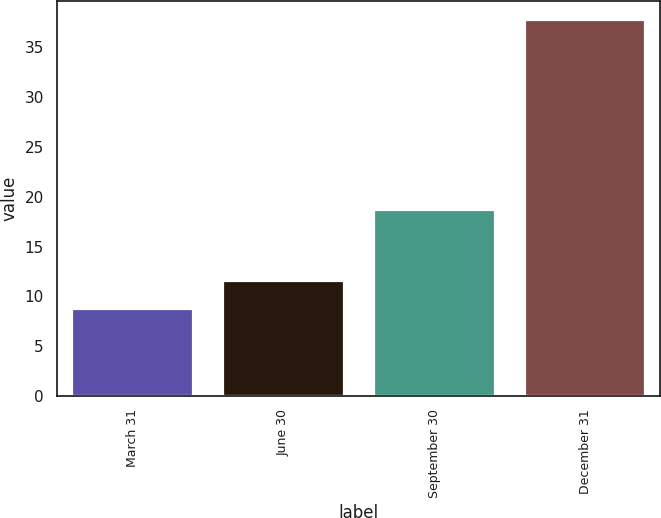<chart> <loc_0><loc_0><loc_500><loc_500><bar_chart><fcel>March 31<fcel>June 30<fcel>September 30<fcel>December 31<nl><fcel>8.69<fcel>11.59<fcel>18.66<fcel>37.72<nl></chart> 